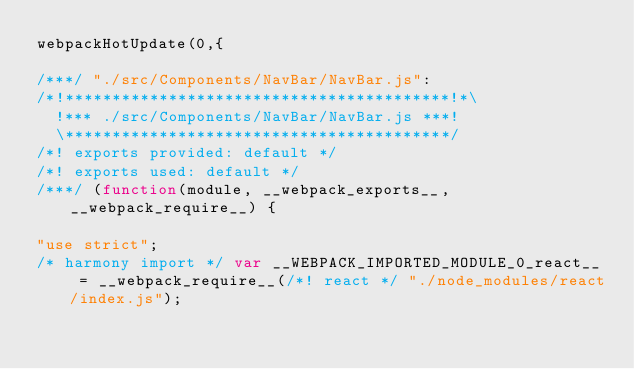<code> <loc_0><loc_0><loc_500><loc_500><_JavaScript_>webpackHotUpdate(0,{

/***/ "./src/Components/NavBar/NavBar.js":
/*!*****************************************!*\
  !*** ./src/Components/NavBar/NavBar.js ***!
  \*****************************************/
/*! exports provided: default */
/*! exports used: default */
/***/ (function(module, __webpack_exports__, __webpack_require__) {

"use strict";
/* harmony import */ var __WEBPACK_IMPORTED_MODULE_0_react__ = __webpack_require__(/*! react */ "./node_modules/react/index.js");</code> 